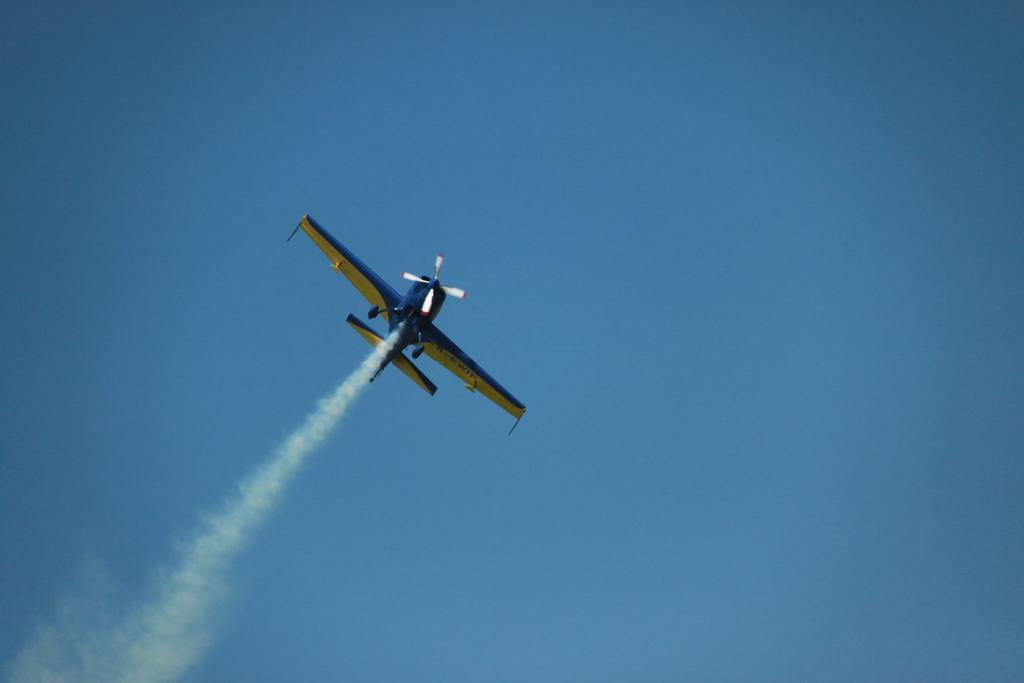Can you describe this image briefly? An aeroplane is flying in the air. It is in blue and yellow color and this is the sky in blue color. 